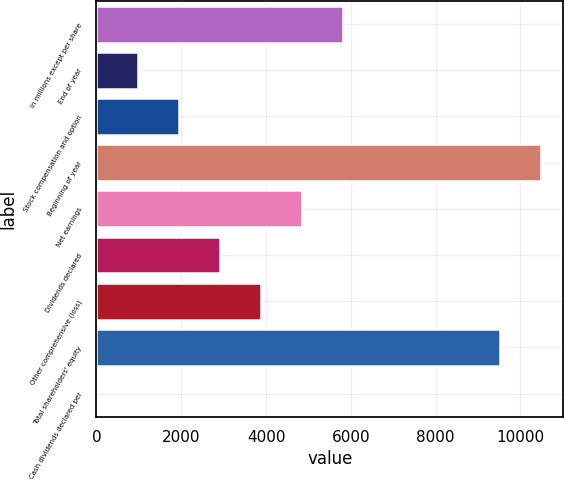Convert chart. <chart><loc_0><loc_0><loc_500><loc_500><bar_chart><fcel>in millions except per share<fcel>End of year<fcel>Stock compensation and option<fcel>Beginning of year<fcel>Net earnings<fcel>Dividends declared<fcel>Other comprehensive (loss)<fcel>Total shareholders' equity<fcel>Cash dividends declared per<nl><fcel>5820.28<fcel>971.84<fcel>1941.53<fcel>10483.7<fcel>4850.59<fcel>2911.22<fcel>3880.9<fcel>9514<fcel>2.15<nl></chart> 